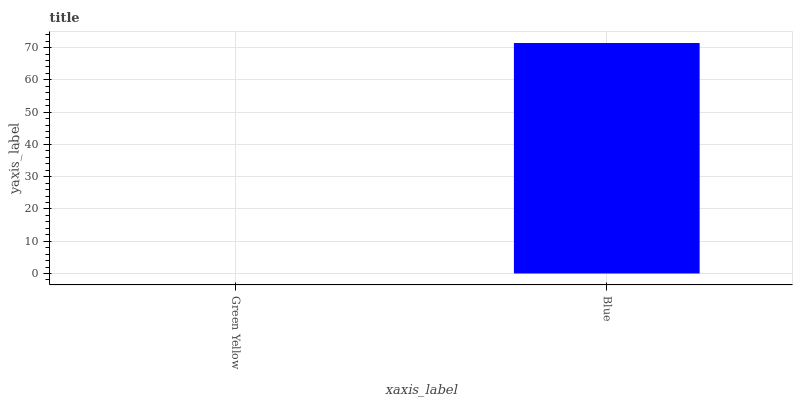Is Green Yellow the minimum?
Answer yes or no. Yes. Is Blue the maximum?
Answer yes or no. Yes. Is Blue the minimum?
Answer yes or no. No. Is Blue greater than Green Yellow?
Answer yes or no. Yes. Is Green Yellow less than Blue?
Answer yes or no. Yes. Is Green Yellow greater than Blue?
Answer yes or no. No. Is Blue less than Green Yellow?
Answer yes or no. No. Is Blue the high median?
Answer yes or no. Yes. Is Green Yellow the low median?
Answer yes or no. Yes. Is Green Yellow the high median?
Answer yes or no. No. Is Blue the low median?
Answer yes or no. No. 